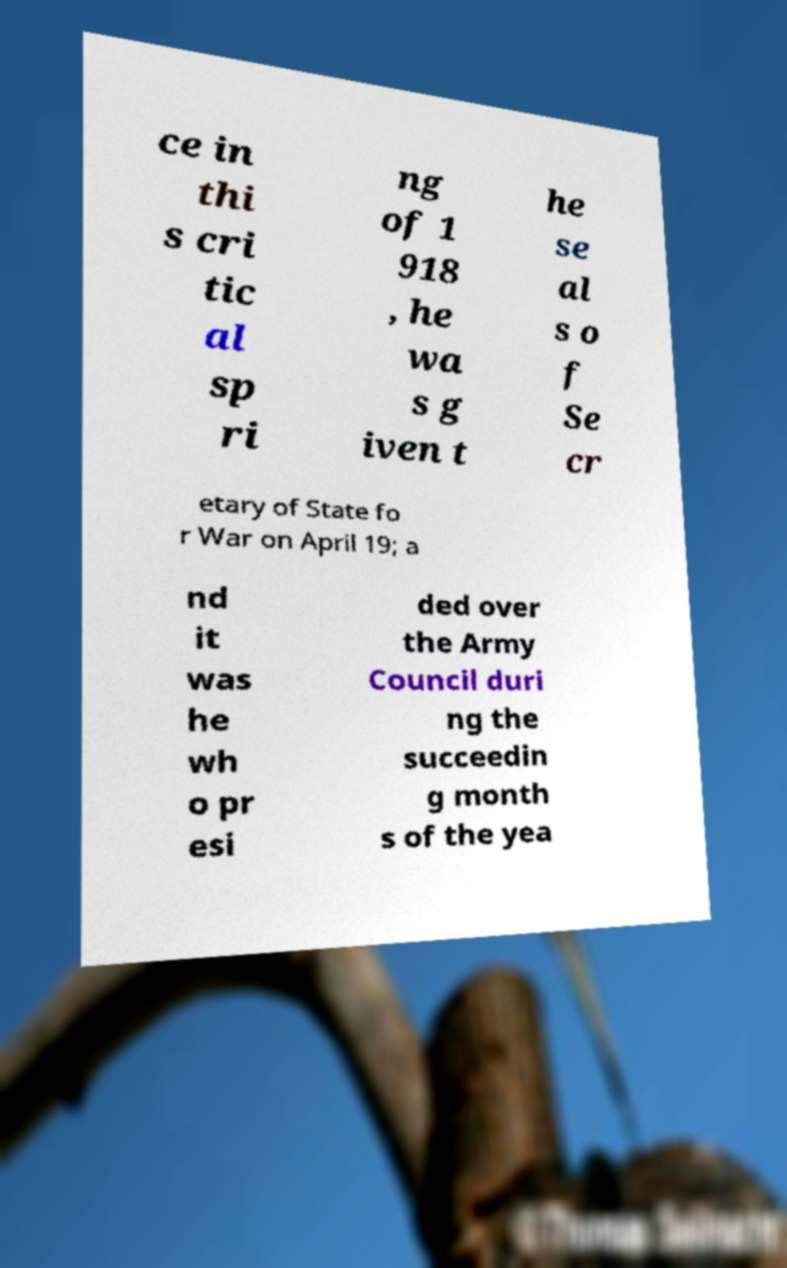Can you read and provide the text displayed in the image?This photo seems to have some interesting text. Can you extract and type it out for me? ce in thi s cri tic al sp ri ng of 1 918 , he wa s g iven t he se al s o f Se cr etary of State fo r War on April 19; a nd it was he wh o pr esi ded over the Army Council duri ng the succeedin g month s of the yea 